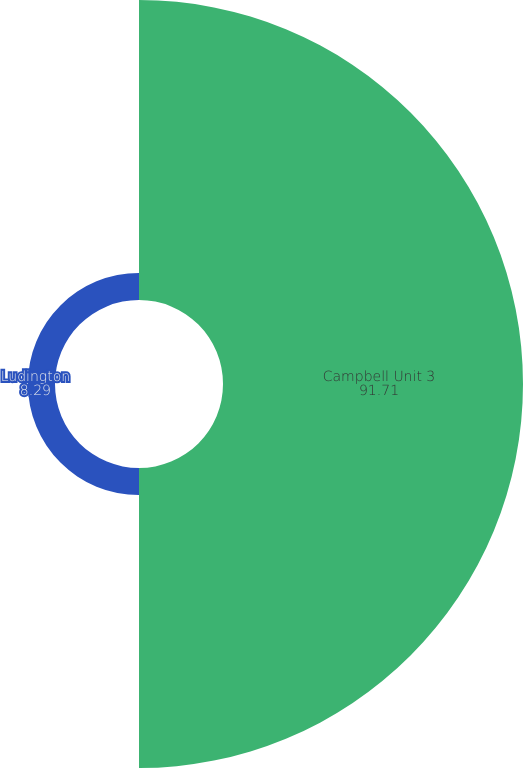Convert chart. <chart><loc_0><loc_0><loc_500><loc_500><pie_chart><fcel>Campbell Unit 3<fcel>Ludington<nl><fcel>91.71%<fcel>8.29%<nl></chart> 